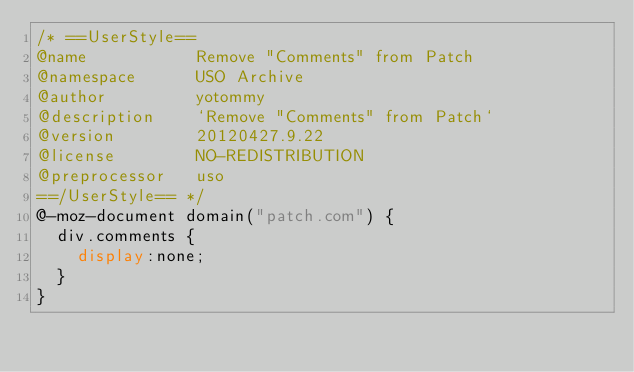<code> <loc_0><loc_0><loc_500><loc_500><_CSS_>/* ==UserStyle==
@name           Remove "Comments" from Patch
@namespace      USO Archive
@author         yotommy
@description    `Remove "Comments" from Patch`
@version        20120427.9.22
@license        NO-REDISTRIBUTION
@preprocessor   uso
==/UserStyle== */
@-moz-document domain("patch.com") {
  div.comments {
    display:none;
  }
}</code> 